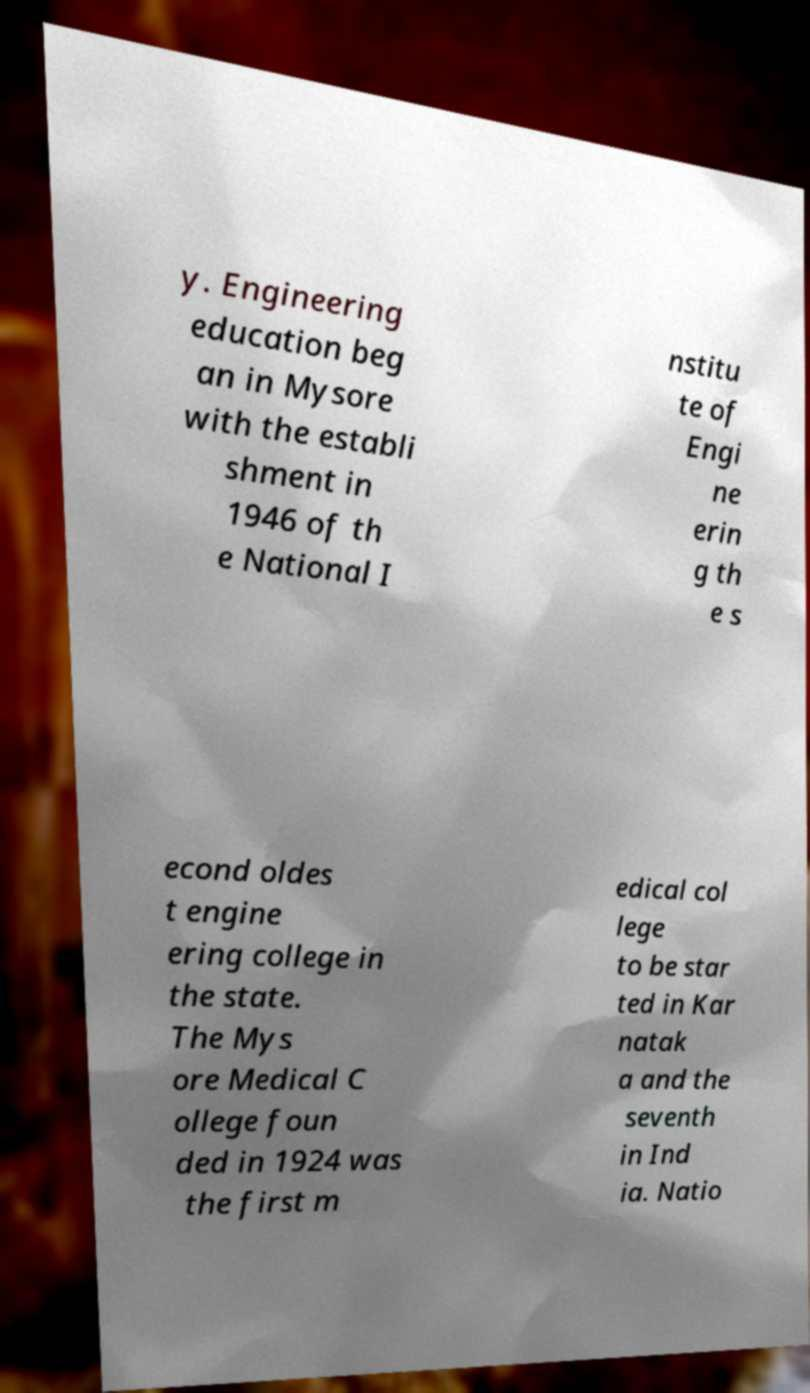For documentation purposes, I need the text within this image transcribed. Could you provide that? y. Engineering education beg an in Mysore with the establi shment in 1946 of th e National I nstitu te of Engi ne erin g th e s econd oldes t engine ering college in the state. The Mys ore Medical C ollege foun ded in 1924 was the first m edical col lege to be star ted in Kar natak a and the seventh in Ind ia. Natio 